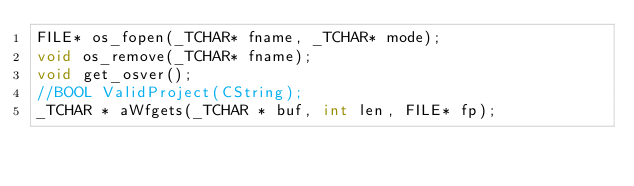Convert code to text. <code><loc_0><loc_0><loc_500><loc_500><_C_>FILE* os_fopen(_TCHAR* fname, _TCHAR* mode);
void os_remove(_TCHAR* fname);
void get_osver();
//BOOL ValidProject(CString);
_TCHAR * aWfgets(_TCHAR * buf, int len, FILE* fp);
</code> 